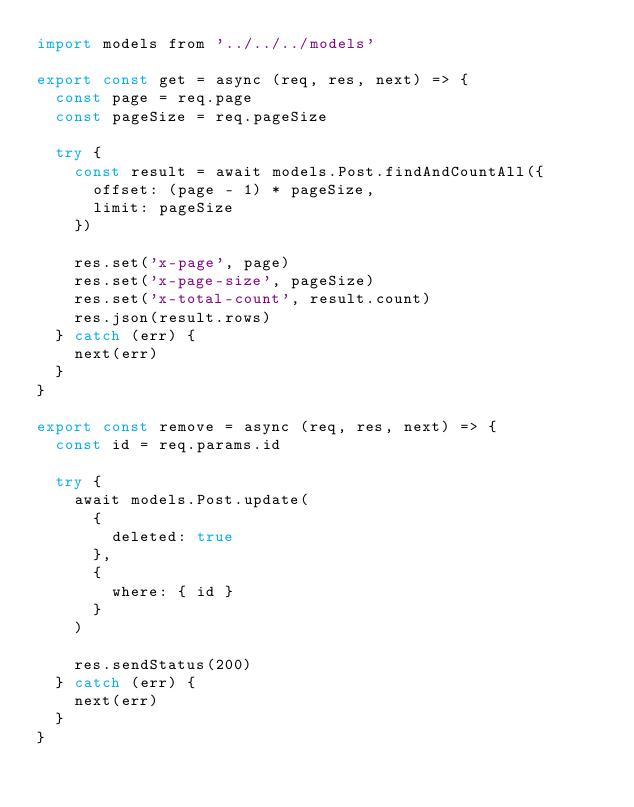<code> <loc_0><loc_0><loc_500><loc_500><_JavaScript_>import models from '../../../models'

export const get = async (req, res, next) => {
  const page = req.page
  const pageSize = req.pageSize

  try {
    const result = await models.Post.findAndCountAll({
      offset: (page - 1) * pageSize,
      limit: pageSize
    })

    res.set('x-page', page)
    res.set('x-page-size', pageSize)
    res.set('x-total-count', result.count)
    res.json(result.rows)
  } catch (err) {
    next(err)
  }
}

export const remove = async (req, res, next) => {
  const id = req.params.id

  try {
    await models.Post.update(
      {
        deleted: true
      },
      {
        where: { id }
      }
    )

    res.sendStatus(200)
  } catch (err) {
    next(err)
  }
}
</code> 